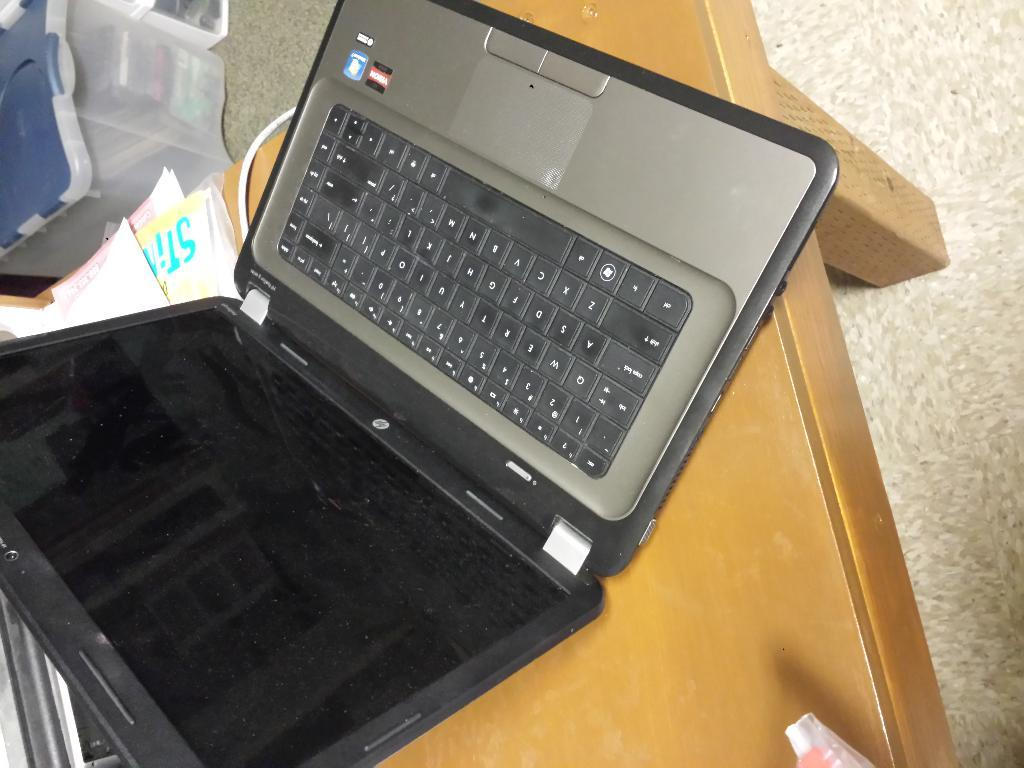<image>
Share a concise interpretation of the image provided. an HP computer lap top is on a coffee table 